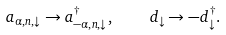Convert formula to latex. <formula><loc_0><loc_0><loc_500><loc_500>a _ { \alpha , n , \downarrow } \to a _ { - \alpha , n , \downarrow } ^ { \dagger } , \quad d _ { \downarrow } \to - d ^ { \dagger } _ { \downarrow } .</formula> 